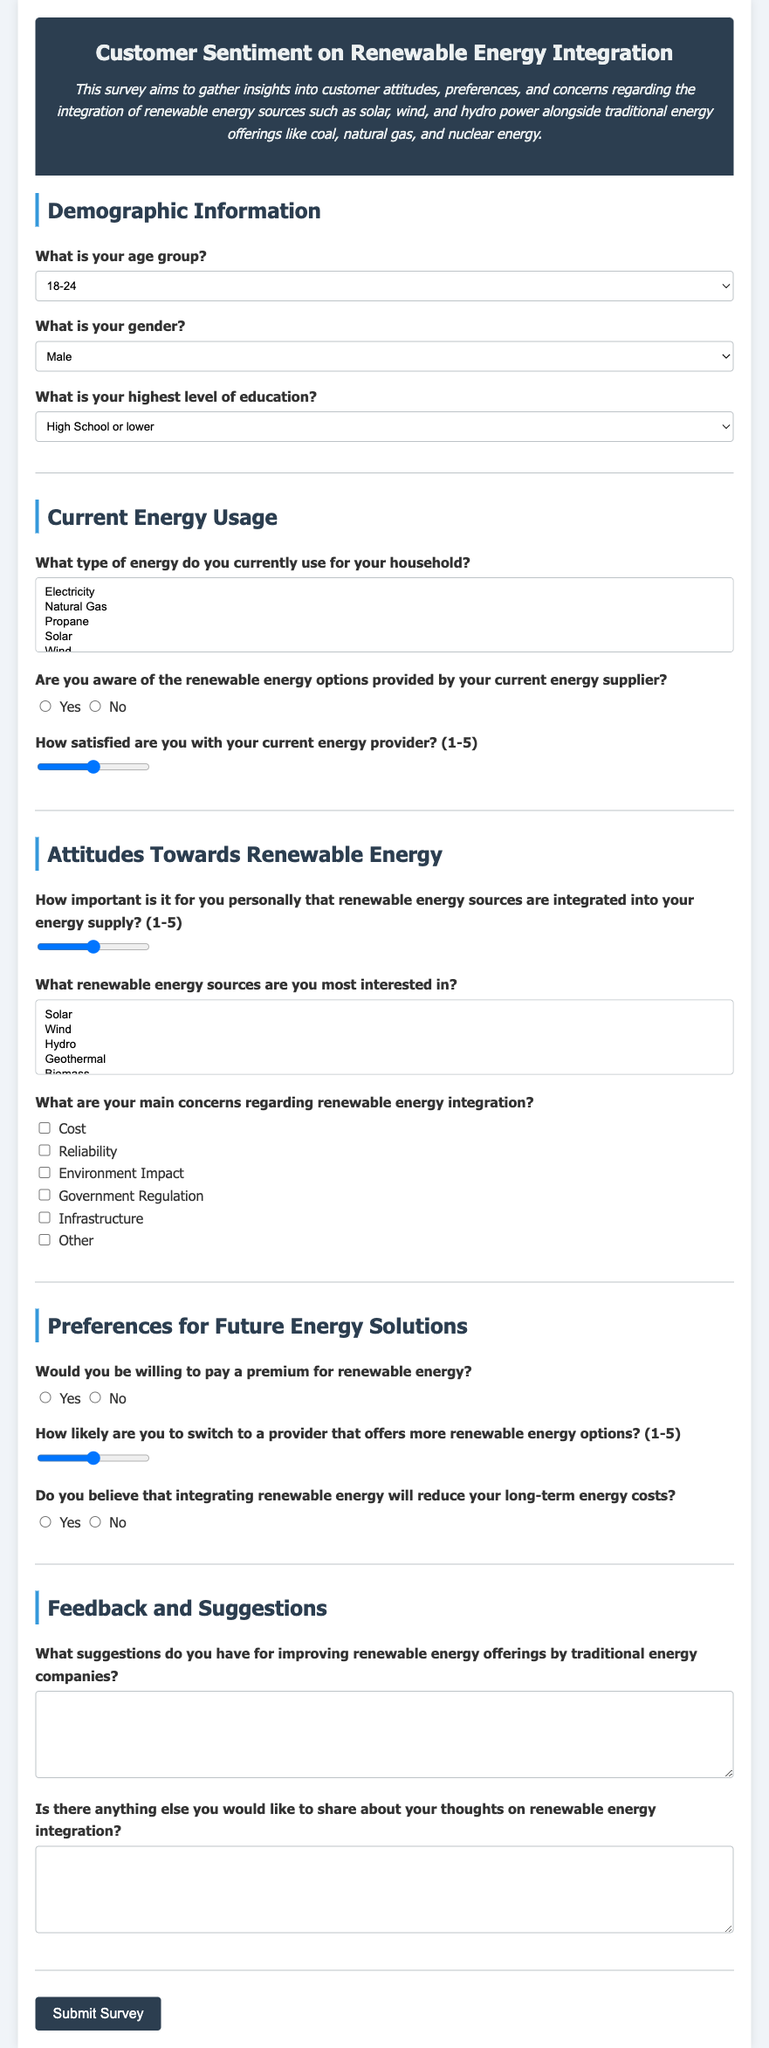What is the title of the questionnaire? The title of the questionnaire is found in the header section of the document.
Answer: Customer Sentiment on Renewable Energy Integration How many age group options are provided? The document lists different age groups in the Demographic Information section.
Answer: Six What is the minimum satisfaction rating scale for energy providers? The satisfaction rating is specified in the Current Energy Usage section.
Answer: 1 Which types of renewable energy sources are mentioned in the options? The Renewable Energy sources are listed under Attitudes Towards Renewable Energy section.
Answer: Solar, Wind, Hydro, Geothermal, Biomass What demographic group has the option "Prefer not to say"? The gender options provided in the Demographic Information section include this choice.
Answer: Gender What is the purpose of this survey? The purpose is stated in the description beneath the title in the document.
Answer: To gather insights into customer attitudes, preferences, and concerns regarding renewable energy sources Is there an option for customer feedback in the questionnaire? The feedback and suggestions section includes questions for open-ended responses.
Answer: Yes 